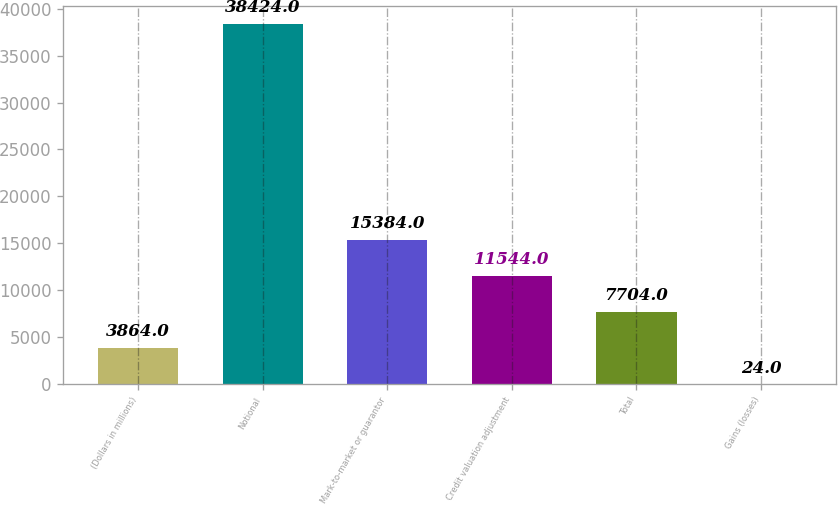<chart> <loc_0><loc_0><loc_500><loc_500><bar_chart><fcel>(Dollars in millions)<fcel>Notional<fcel>Mark-to-market or guarantor<fcel>Credit valuation adjustment<fcel>Total<fcel>Gains (losses)<nl><fcel>3864<fcel>38424<fcel>15384<fcel>11544<fcel>7704<fcel>24<nl></chart> 